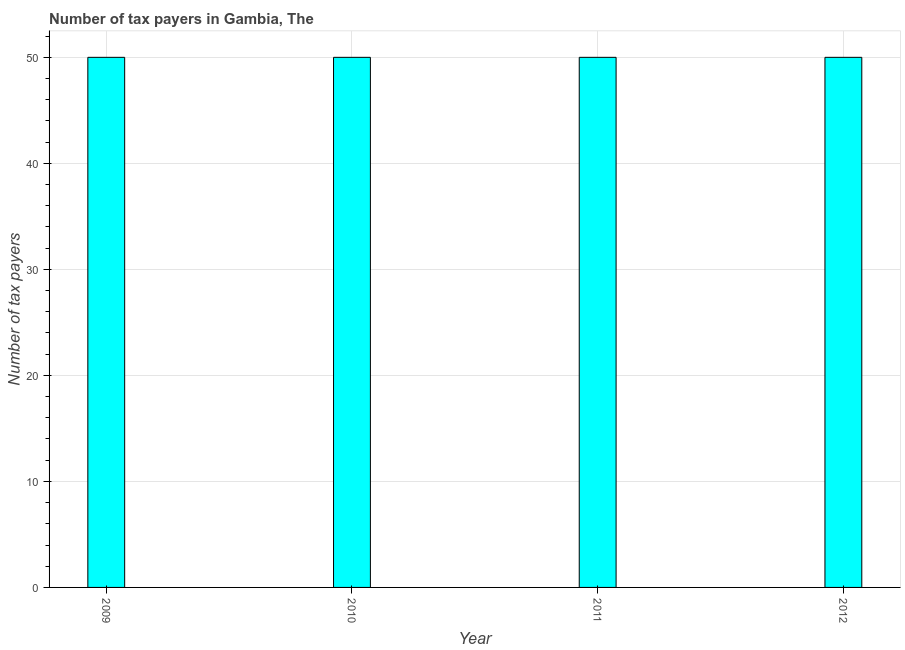Does the graph contain grids?
Make the answer very short. Yes. What is the title of the graph?
Give a very brief answer. Number of tax payers in Gambia, The. What is the label or title of the X-axis?
Provide a succinct answer. Year. What is the label or title of the Y-axis?
Make the answer very short. Number of tax payers. Across all years, what is the maximum number of tax payers?
Your response must be concise. 50. What is the sum of the number of tax payers?
Offer a very short reply. 200. What is the median number of tax payers?
Offer a very short reply. 50. What is the ratio of the number of tax payers in 2009 to that in 2012?
Keep it short and to the point. 1. Is the difference between the number of tax payers in 2010 and 2012 greater than the difference between any two years?
Your response must be concise. Yes. How many bars are there?
Your response must be concise. 4. How many years are there in the graph?
Your response must be concise. 4. Are the values on the major ticks of Y-axis written in scientific E-notation?
Offer a very short reply. No. What is the Number of tax payers in 2009?
Your answer should be compact. 50. What is the Number of tax payers in 2010?
Offer a terse response. 50. What is the difference between the Number of tax payers in 2009 and 2011?
Offer a terse response. 0. What is the difference between the Number of tax payers in 2009 and 2012?
Your response must be concise. 0. What is the difference between the Number of tax payers in 2010 and 2011?
Offer a terse response. 0. What is the difference between the Number of tax payers in 2010 and 2012?
Your response must be concise. 0. What is the ratio of the Number of tax payers in 2009 to that in 2010?
Make the answer very short. 1. What is the ratio of the Number of tax payers in 2009 to that in 2011?
Your answer should be very brief. 1. What is the ratio of the Number of tax payers in 2009 to that in 2012?
Your response must be concise. 1. What is the ratio of the Number of tax payers in 2010 to that in 2012?
Offer a terse response. 1. 